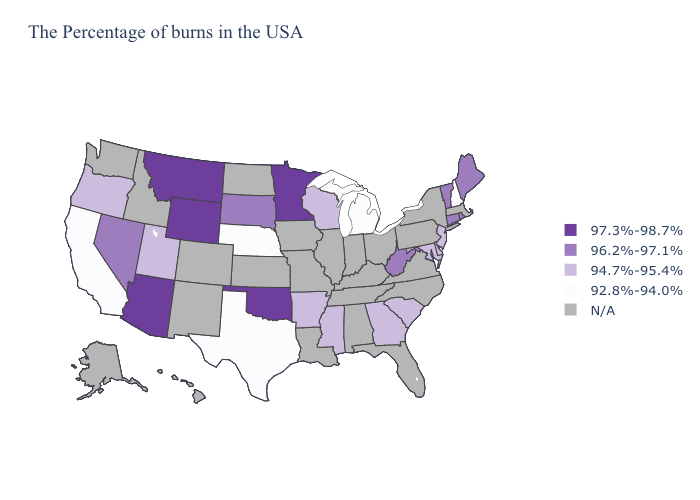What is the highest value in the USA?
Short answer required. 97.3%-98.7%. Name the states that have a value in the range 94.7%-95.4%?
Be succinct. New Jersey, Delaware, Maryland, South Carolina, Georgia, Wisconsin, Mississippi, Arkansas, Utah, Oregon. Name the states that have a value in the range 94.7%-95.4%?
Quick response, please. New Jersey, Delaware, Maryland, South Carolina, Georgia, Wisconsin, Mississippi, Arkansas, Utah, Oregon. What is the lowest value in states that border Mississippi?
Answer briefly. 94.7%-95.4%. Name the states that have a value in the range 94.7%-95.4%?
Be succinct. New Jersey, Delaware, Maryland, South Carolina, Georgia, Wisconsin, Mississippi, Arkansas, Utah, Oregon. Name the states that have a value in the range N/A?
Concise answer only. Massachusetts, New York, Pennsylvania, Virginia, North Carolina, Ohio, Florida, Kentucky, Indiana, Alabama, Tennessee, Illinois, Louisiana, Missouri, Iowa, Kansas, North Dakota, Colorado, New Mexico, Idaho, Washington, Alaska, Hawaii. What is the value of New York?
Concise answer only. N/A. What is the value of Alabama?
Give a very brief answer. N/A. Name the states that have a value in the range 97.3%-98.7%?
Concise answer only. Minnesota, Oklahoma, Wyoming, Montana, Arizona. What is the value of Rhode Island?
Answer briefly. 96.2%-97.1%. What is the highest value in the USA?
Short answer required. 97.3%-98.7%. What is the value of Massachusetts?
Be succinct. N/A. Name the states that have a value in the range 92.8%-94.0%?
Keep it brief. New Hampshire, Michigan, Nebraska, Texas, California. Does Minnesota have the highest value in the MidWest?
Be succinct. Yes. 